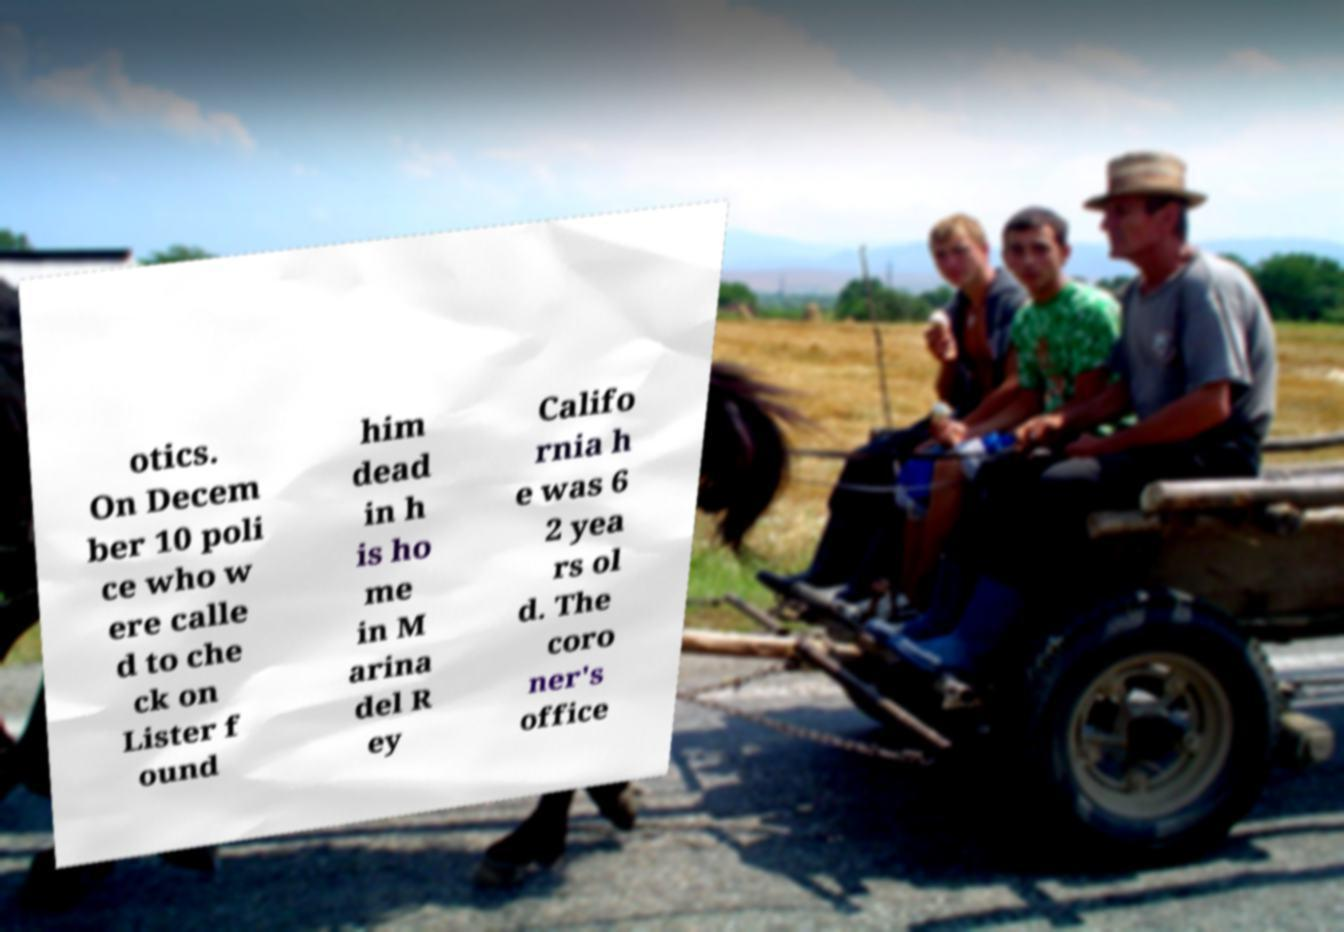Can you read and provide the text displayed in the image?This photo seems to have some interesting text. Can you extract and type it out for me? otics. On Decem ber 10 poli ce who w ere calle d to che ck on Lister f ound him dead in h is ho me in M arina del R ey Califo rnia h e was 6 2 yea rs ol d. The coro ner's office 